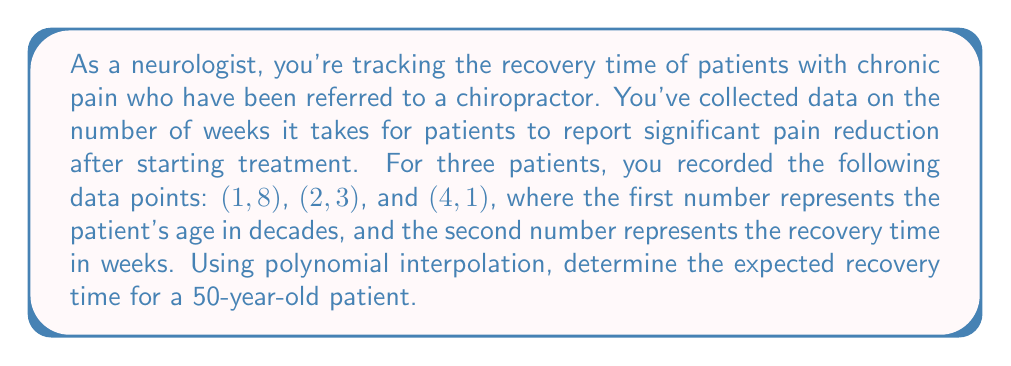Help me with this question. To solve this problem, we'll use Lagrange polynomial interpolation to find a quadratic function that fits the given data points. Then, we'll use this function to predict the recovery time for a 50-year-old patient.

Step 1: Set up the Lagrange interpolation formula
The Lagrange interpolation polynomial is given by:
$$P(x) = \sum_{i=1}^n y_i \cdot L_i(x)$$
where $L_i(x)$ are the Lagrange basis polynomials:
$$L_i(x) = \prod_{j=1, j \neq i}^n \frac{x - x_j}{x_i - x_j}$$

Step 2: Calculate the Lagrange basis polynomials
For our three data points (1, 8), (2, 3), and (4, 1):

$$L_1(x) = \frac{(x-2)(x-4)}{(1-2)(1-4)} = \frac{(x-2)(x-4)}{3}$$
$$L_2(x) = \frac{(x-1)(x-4)}{(2-1)(2-4)} = -\frac{(x-1)(x-4)}{2}$$
$$L_3(x) = \frac{(x-1)(x-2)}{(4-1)(4-2)} = \frac{(x-1)(x-2)}{6}$$

Step 3: Construct the interpolation polynomial
$$P(x) = 8 \cdot \frac{(x-2)(x-4)}{3} + 3 \cdot \left(-\frac{(x-1)(x-4)}{2}\right) + 1 \cdot \frac{(x-1)(x-2)}{6}$$

Step 4: Simplify the polynomial
Expanding and combining like terms, we get:
$$P(x) = \frac{1}{6}x^2 - \frac{13}{6}x + 8$$

Step 5: Calculate the recovery time for a 50-year-old patient
For a 50-year-old patient, x = 5 (age in decades). Substitute this into our polynomial:

$$P(5) = \frac{1}{6}(5)^2 - \frac{13}{6}(5) + 8$$
$$= \frac{25}{6} - \frac{65}{6} + 8$$
$$= -\frac{40}{6} + 8$$
$$= -\frac{20}{3} + 8$$
$$= 8 - \frac{20}{3}$$
$$= \frac{24}{3} - \frac{20}{3}$$
$$= \frac{4}{3}$$

Therefore, the expected recovery time for a 50-year-old patient is $\frac{4}{3}$ weeks.
Answer: $\frac{4}{3}$ weeks 